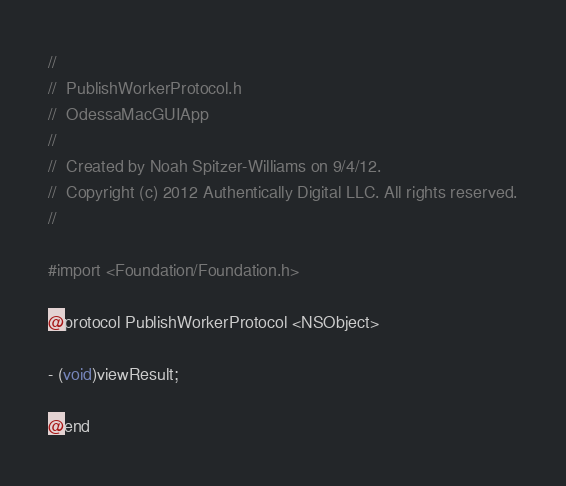Convert code to text. <code><loc_0><loc_0><loc_500><loc_500><_C_>//
//  PublishWorkerProtocol.h
//  OdessaMacGUIApp
//
//  Created by Noah Spitzer-Williams on 9/4/12.
//  Copyright (c) 2012 Authentically Digital LLC. All rights reserved.
//

#import <Foundation/Foundation.h>

@protocol PublishWorkerProtocol <NSObject>

- (void)viewResult;

@end
</code> 